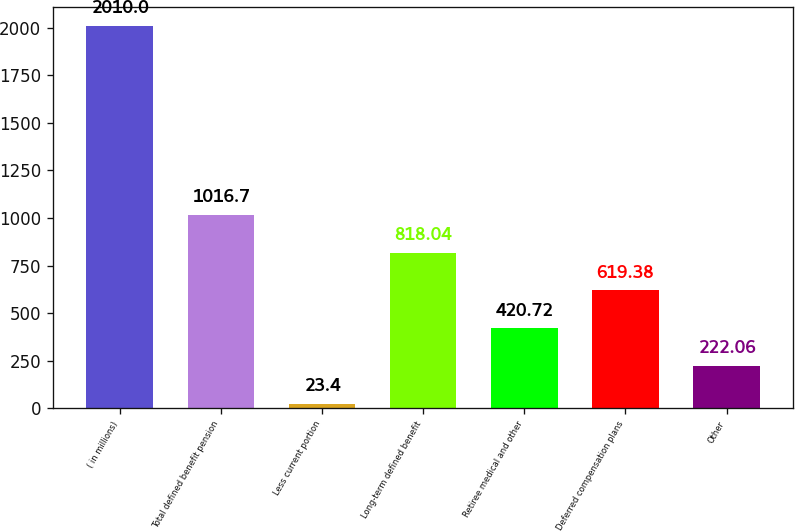Convert chart to OTSL. <chart><loc_0><loc_0><loc_500><loc_500><bar_chart><fcel>( in millions)<fcel>Total defined benefit pension<fcel>Less current portion<fcel>Long-term defined benefit<fcel>Retiree medical and other<fcel>Deferred compensation plans<fcel>Other<nl><fcel>2010<fcel>1016.7<fcel>23.4<fcel>818.04<fcel>420.72<fcel>619.38<fcel>222.06<nl></chart> 